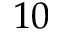<formula> <loc_0><loc_0><loc_500><loc_500>1 0</formula> 